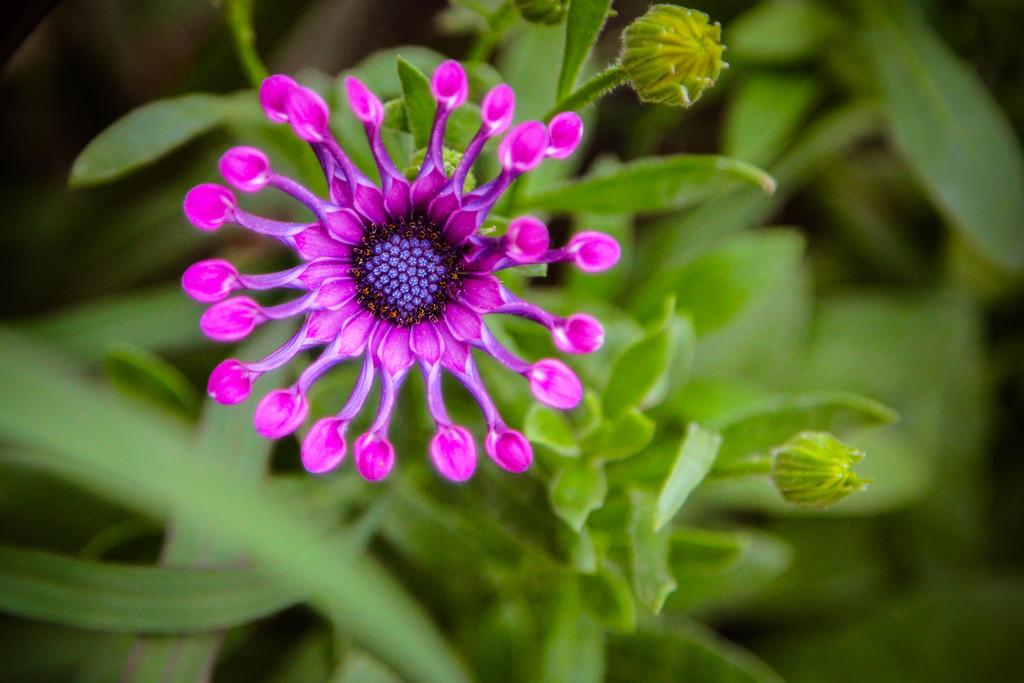What is the main subject of the picture? There is a flower in the picture. What color is the flower? The flower is pink in color. Are there any unopened parts on the flower? Yes, there are buds on the flower. What else is present on the flower besides the buds? There are leaves on the flower. Can you describe the background of the image? The backdrop of the image is blurred. What type of table is supporting the flower in the image? There is no table present in the image; the flower is likely in a vase or on a surface that is not visible. 